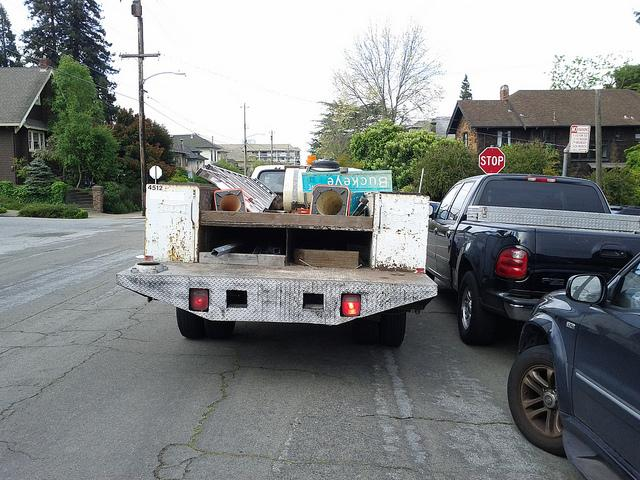Asphalts are used to construct what?

Choices:
A) house
B) roads
C) building
D) harbor roads 